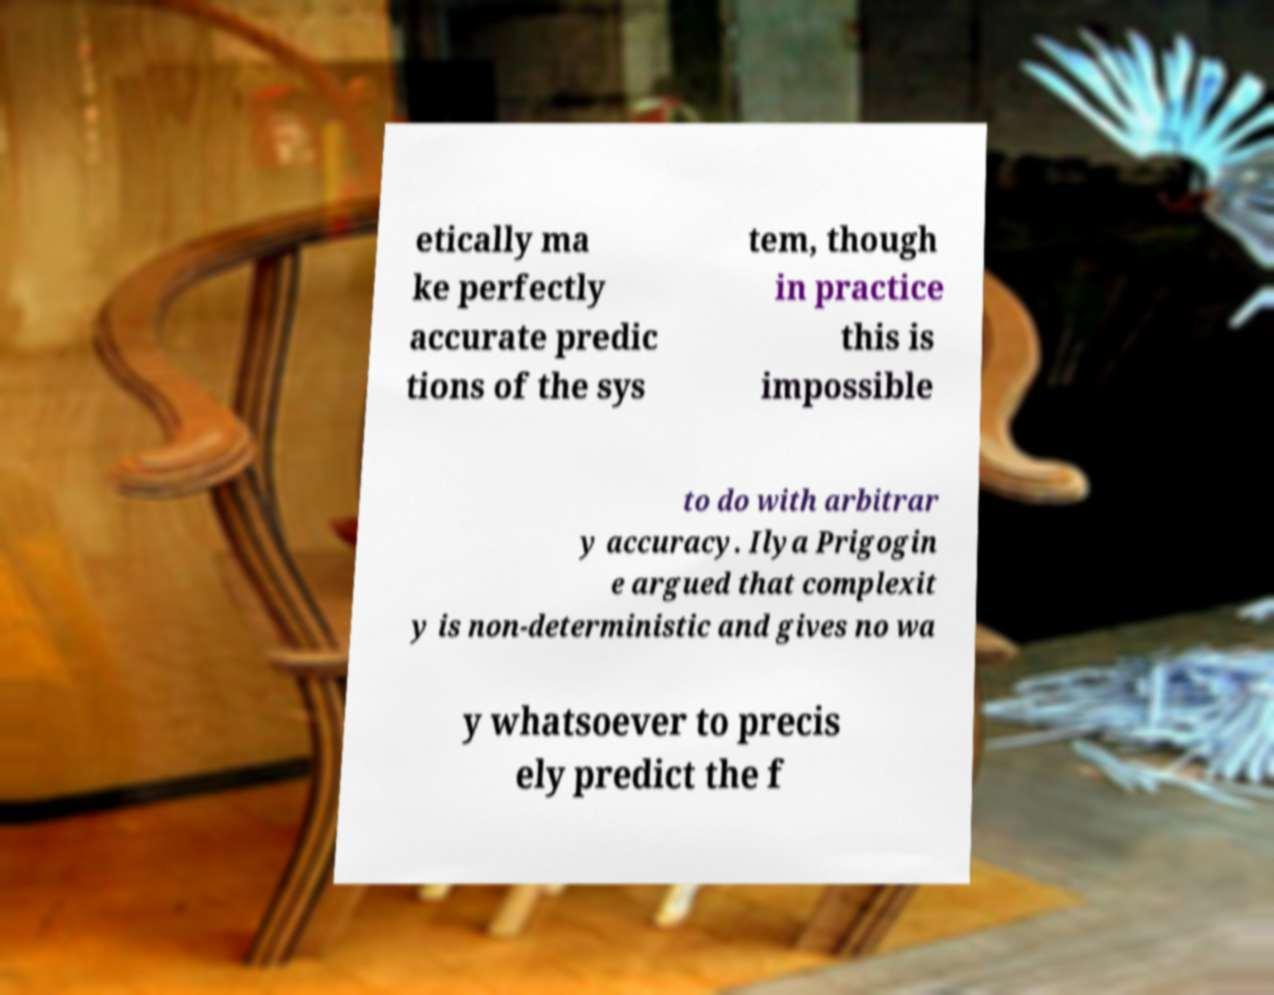Please identify and transcribe the text found in this image. etically ma ke perfectly accurate predic tions of the sys tem, though in practice this is impossible to do with arbitrar y accuracy. Ilya Prigogin e argued that complexit y is non-deterministic and gives no wa y whatsoever to precis ely predict the f 